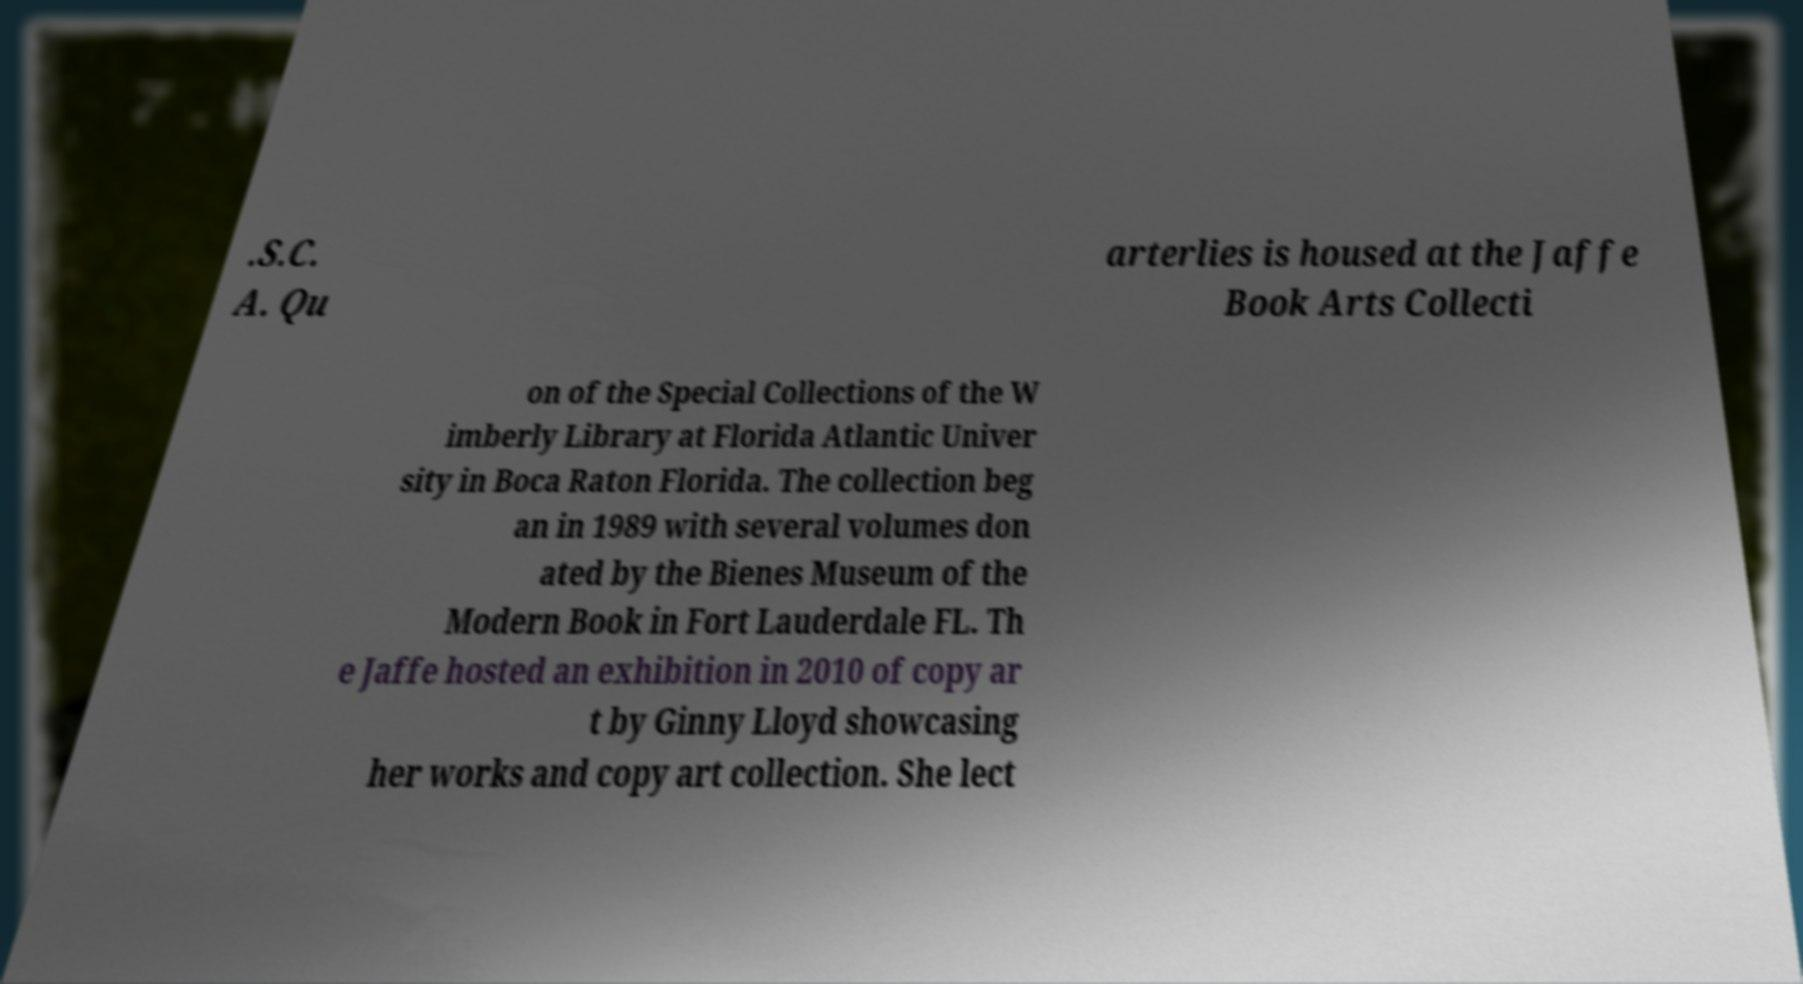Could you extract and type out the text from this image? .S.C. A. Qu arterlies is housed at the Jaffe Book Arts Collecti on of the Special Collections of the W imberly Library at Florida Atlantic Univer sity in Boca Raton Florida. The collection beg an in 1989 with several volumes don ated by the Bienes Museum of the Modern Book in Fort Lauderdale FL. Th e Jaffe hosted an exhibition in 2010 of copy ar t by Ginny Lloyd showcasing her works and copy art collection. She lect 